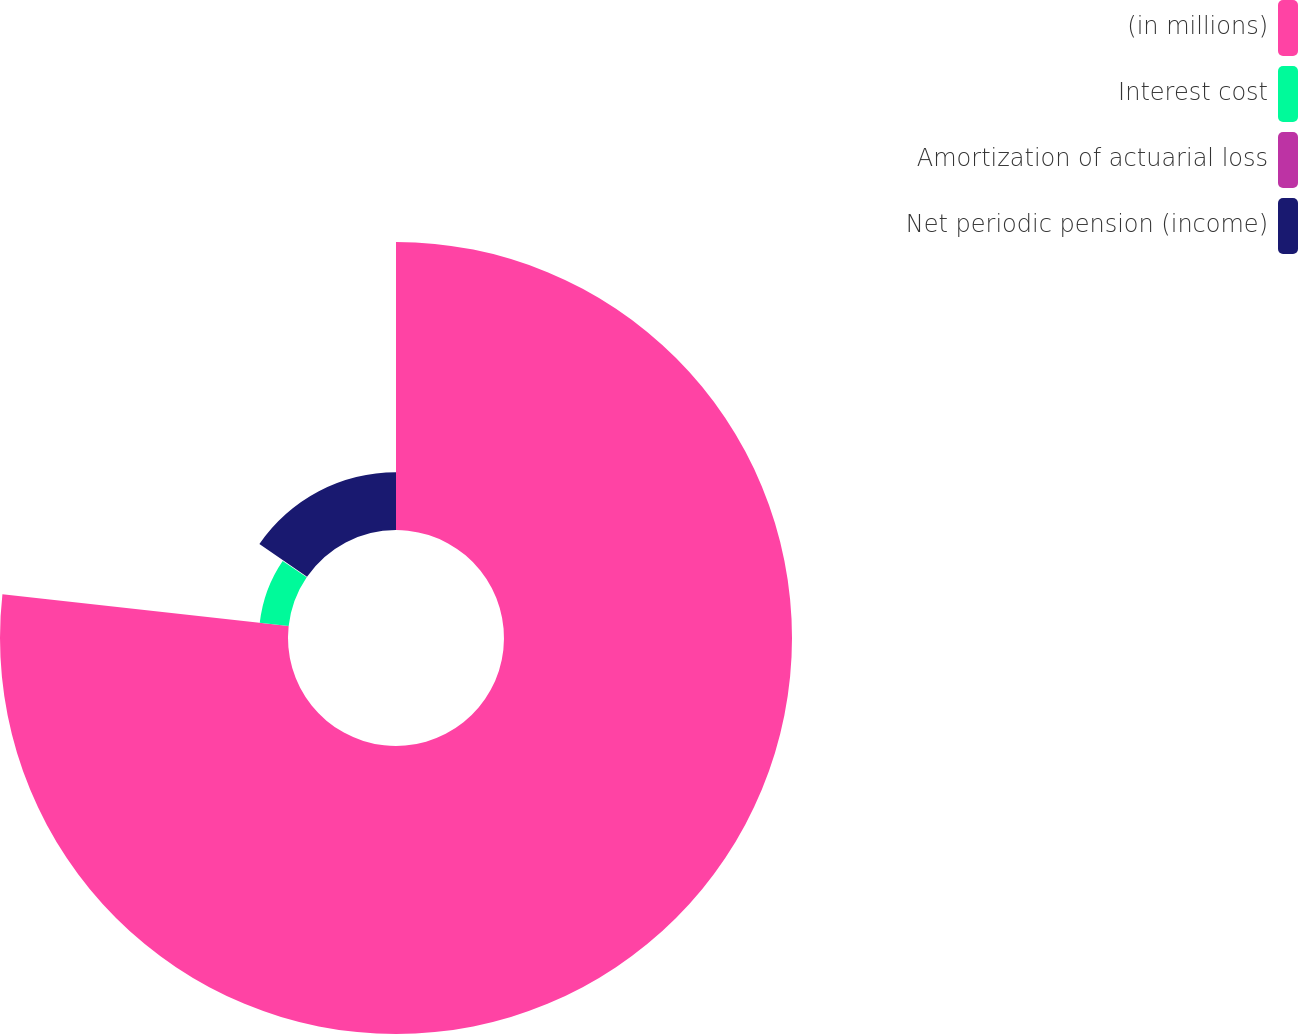Convert chart. <chart><loc_0><loc_0><loc_500><loc_500><pie_chart><fcel>(in millions)<fcel>Interest cost<fcel>Amortization of actuarial loss<fcel>Net periodic pension (income)<nl><fcel>76.76%<fcel>7.75%<fcel>0.08%<fcel>15.41%<nl></chart> 